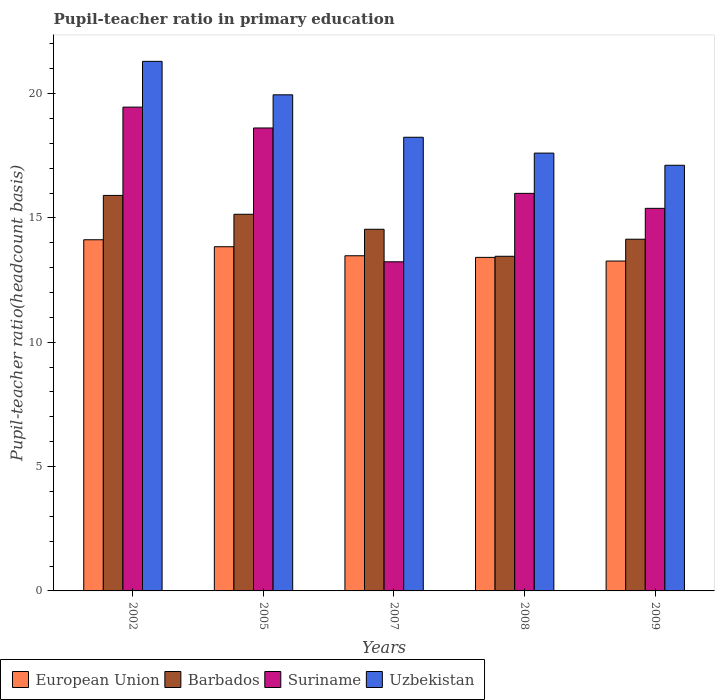How many different coloured bars are there?
Make the answer very short. 4. How many groups of bars are there?
Your response must be concise. 5. Are the number of bars on each tick of the X-axis equal?
Give a very brief answer. Yes. What is the label of the 5th group of bars from the left?
Make the answer very short. 2009. In how many cases, is the number of bars for a given year not equal to the number of legend labels?
Provide a short and direct response. 0. What is the pupil-teacher ratio in primary education in Barbados in 2007?
Your answer should be compact. 14.54. Across all years, what is the maximum pupil-teacher ratio in primary education in European Union?
Keep it short and to the point. 14.12. Across all years, what is the minimum pupil-teacher ratio in primary education in Uzbekistan?
Give a very brief answer. 17.12. In which year was the pupil-teacher ratio in primary education in Barbados maximum?
Keep it short and to the point. 2002. What is the total pupil-teacher ratio in primary education in Barbados in the graph?
Your answer should be very brief. 73.19. What is the difference between the pupil-teacher ratio in primary education in Uzbekistan in 2005 and that in 2009?
Provide a succinct answer. 2.83. What is the difference between the pupil-teacher ratio in primary education in Suriname in 2007 and the pupil-teacher ratio in primary education in Uzbekistan in 2002?
Provide a succinct answer. -8.06. What is the average pupil-teacher ratio in primary education in Suriname per year?
Your answer should be compact. 16.53. In the year 2007, what is the difference between the pupil-teacher ratio in primary education in European Union and pupil-teacher ratio in primary education in Suriname?
Ensure brevity in your answer.  0.24. What is the ratio of the pupil-teacher ratio in primary education in Barbados in 2005 to that in 2008?
Offer a very short reply. 1.13. Is the difference between the pupil-teacher ratio in primary education in European Union in 2002 and 2005 greater than the difference between the pupil-teacher ratio in primary education in Suriname in 2002 and 2005?
Provide a succinct answer. No. What is the difference between the highest and the second highest pupil-teacher ratio in primary education in Barbados?
Provide a short and direct response. 0.76. What is the difference between the highest and the lowest pupil-teacher ratio in primary education in European Union?
Provide a succinct answer. 0.86. Is the sum of the pupil-teacher ratio in primary education in Uzbekistan in 2005 and 2008 greater than the maximum pupil-teacher ratio in primary education in Barbados across all years?
Provide a succinct answer. Yes. What does the 4th bar from the left in 2008 represents?
Offer a terse response. Uzbekistan. What does the 4th bar from the right in 2007 represents?
Make the answer very short. European Union. Is it the case that in every year, the sum of the pupil-teacher ratio in primary education in European Union and pupil-teacher ratio in primary education in Barbados is greater than the pupil-teacher ratio in primary education in Uzbekistan?
Keep it short and to the point. Yes. How many bars are there?
Provide a short and direct response. 20. How many years are there in the graph?
Your answer should be very brief. 5. Are the values on the major ticks of Y-axis written in scientific E-notation?
Keep it short and to the point. No. Does the graph contain any zero values?
Keep it short and to the point. No. How are the legend labels stacked?
Keep it short and to the point. Horizontal. What is the title of the graph?
Your response must be concise. Pupil-teacher ratio in primary education. Does "Slovak Republic" appear as one of the legend labels in the graph?
Offer a very short reply. No. What is the label or title of the Y-axis?
Offer a terse response. Pupil-teacher ratio(headcount basis). What is the Pupil-teacher ratio(headcount basis) of European Union in 2002?
Your response must be concise. 14.12. What is the Pupil-teacher ratio(headcount basis) in Barbados in 2002?
Your answer should be very brief. 15.9. What is the Pupil-teacher ratio(headcount basis) in Suriname in 2002?
Offer a terse response. 19.45. What is the Pupil-teacher ratio(headcount basis) in Uzbekistan in 2002?
Offer a very short reply. 21.29. What is the Pupil-teacher ratio(headcount basis) of European Union in 2005?
Your answer should be compact. 13.84. What is the Pupil-teacher ratio(headcount basis) of Barbados in 2005?
Offer a very short reply. 15.15. What is the Pupil-teacher ratio(headcount basis) of Suriname in 2005?
Provide a succinct answer. 18.62. What is the Pupil-teacher ratio(headcount basis) in Uzbekistan in 2005?
Ensure brevity in your answer.  19.95. What is the Pupil-teacher ratio(headcount basis) of European Union in 2007?
Provide a succinct answer. 13.48. What is the Pupil-teacher ratio(headcount basis) of Barbados in 2007?
Offer a very short reply. 14.54. What is the Pupil-teacher ratio(headcount basis) in Suriname in 2007?
Your response must be concise. 13.23. What is the Pupil-teacher ratio(headcount basis) in Uzbekistan in 2007?
Make the answer very short. 18.24. What is the Pupil-teacher ratio(headcount basis) in European Union in 2008?
Your answer should be very brief. 13.41. What is the Pupil-teacher ratio(headcount basis) of Barbados in 2008?
Ensure brevity in your answer.  13.46. What is the Pupil-teacher ratio(headcount basis) of Suriname in 2008?
Your response must be concise. 15.99. What is the Pupil-teacher ratio(headcount basis) of Uzbekistan in 2008?
Provide a succinct answer. 17.61. What is the Pupil-teacher ratio(headcount basis) in European Union in 2009?
Give a very brief answer. 13.27. What is the Pupil-teacher ratio(headcount basis) of Barbados in 2009?
Give a very brief answer. 14.14. What is the Pupil-teacher ratio(headcount basis) in Suriname in 2009?
Your answer should be compact. 15.38. What is the Pupil-teacher ratio(headcount basis) in Uzbekistan in 2009?
Your answer should be very brief. 17.12. Across all years, what is the maximum Pupil-teacher ratio(headcount basis) in European Union?
Provide a succinct answer. 14.12. Across all years, what is the maximum Pupil-teacher ratio(headcount basis) of Barbados?
Give a very brief answer. 15.9. Across all years, what is the maximum Pupil-teacher ratio(headcount basis) in Suriname?
Offer a terse response. 19.45. Across all years, what is the maximum Pupil-teacher ratio(headcount basis) in Uzbekistan?
Make the answer very short. 21.29. Across all years, what is the minimum Pupil-teacher ratio(headcount basis) of European Union?
Your answer should be compact. 13.27. Across all years, what is the minimum Pupil-teacher ratio(headcount basis) in Barbados?
Make the answer very short. 13.46. Across all years, what is the minimum Pupil-teacher ratio(headcount basis) in Suriname?
Give a very brief answer. 13.23. Across all years, what is the minimum Pupil-teacher ratio(headcount basis) in Uzbekistan?
Your answer should be compact. 17.12. What is the total Pupil-teacher ratio(headcount basis) in European Union in the graph?
Keep it short and to the point. 68.12. What is the total Pupil-teacher ratio(headcount basis) in Barbados in the graph?
Make the answer very short. 73.19. What is the total Pupil-teacher ratio(headcount basis) in Suriname in the graph?
Keep it short and to the point. 82.67. What is the total Pupil-teacher ratio(headcount basis) in Uzbekistan in the graph?
Your answer should be very brief. 94.21. What is the difference between the Pupil-teacher ratio(headcount basis) of European Union in 2002 and that in 2005?
Make the answer very short. 0.28. What is the difference between the Pupil-teacher ratio(headcount basis) of Barbados in 2002 and that in 2005?
Your response must be concise. 0.76. What is the difference between the Pupil-teacher ratio(headcount basis) of Suriname in 2002 and that in 2005?
Ensure brevity in your answer.  0.84. What is the difference between the Pupil-teacher ratio(headcount basis) of Uzbekistan in 2002 and that in 2005?
Offer a terse response. 1.35. What is the difference between the Pupil-teacher ratio(headcount basis) in European Union in 2002 and that in 2007?
Keep it short and to the point. 0.64. What is the difference between the Pupil-teacher ratio(headcount basis) of Barbados in 2002 and that in 2007?
Your answer should be very brief. 1.36. What is the difference between the Pupil-teacher ratio(headcount basis) in Suriname in 2002 and that in 2007?
Keep it short and to the point. 6.22. What is the difference between the Pupil-teacher ratio(headcount basis) of Uzbekistan in 2002 and that in 2007?
Your answer should be compact. 3.05. What is the difference between the Pupil-teacher ratio(headcount basis) of European Union in 2002 and that in 2008?
Provide a short and direct response. 0.71. What is the difference between the Pupil-teacher ratio(headcount basis) of Barbados in 2002 and that in 2008?
Your answer should be very brief. 2.45. What is the difference between the Pupil-teacher ratio(headcount basis) in Suriname in 2002 and that in 2008?
Ensure brevity in your answer.  3.47. What is the difference between the Pupil-teacher ratio(headcount basis) of Uzbekistan in 2002 and that in 2008?
Your response must be concise. 3.69. What is the difference between the Pupil-teacher ratio(headcount basis) in European Union in 2002 and that in 2009?
Offer a very short reply. 0.86. What is the difference between the Pupil-teacher ratio(headcount basis) in Barbados in 2002 and that in 2009?
Ensure brevity in your answer.  1.76. What is the difference between the Pupil-teacher ratio(headcount basis) in Suriname in 2002 and that in 2009?
Keep it short and to the point. 4.07. What is the difference between the Pupil-teacher ratio(headcount basis) of Uzbekistan in 2002 and that in 2009?
Your response must be concise. 4.18. What is the difference between the Pupil-teacher ratio(headcount basis) in European Union in 2005 and that in 2007?
Give a very brief answer. 0.36. What is the difference between the Pupil-teacher ratio(headcount basis) of Barbados in 2005 and that in 2007?
Your answer should be very brief. 0.6. What is the difference between the Pupil-teacher ratio(headcount basis) in Suriname in 2005 and that in 2007?
Keep it short and to the point. 5.38. What is the difference between the Pupil-teacher ratio(headcount basis) in Uzbekistan in 2005 and that in 2007?
Offer a very short reply. 1.71. What is the difference between the Pupil-teacher ratio(headcount basis) in European Union in 2005 and that in 2008?
Give a very brief answer. 0.43. What is the difference between the Pupil-teacher ratio(headcount basis) in Barbados in 2005 and that in 2008?
Keep it short and to the point. 1.69. What is the difference between the Pupil-teacher ratio(headcount basis) in Suriname in 2005 and that in 2008?
Give a very brief answer. 2.63. What is the difference between the Pupil-teacher ratio(headcount basis) of Uzbekistan in 2005 and that in 2008?
Provide a succinct answer. 2.34. What is the difference between the Pupil-teacher ratio(headcount basis) of European Union in 2005 and that in 2009?
Keep it short and to the point. 0.58. What is the difference between the Pupil-teacher ratio(headcount basis) of Barbados in 2005 and that in 2009?
Your response must be concise. 1. What is the difference between the Pupil-teacher ratio(headcount basis) in Suriname in 2005 and that in 2009?
Offer a terse response. 3.23. What is the difference between the Pupil-teacher ratio(headcount basis) in Uzbekistan in 2005 and that in 2009?
Ensure brevity in your answer.  2.83. What is the difference between the Pupil-teacher ratio(headcount basis) in European Union in 2007 and that in 2008?
Your response must be concise. 0.07. What is the difference between the Pupil-teacher ratio(headcount basis) in Barbados in 2007 and that in 2008?
Ensure brevity in your answer.  1.09. What is the difference between the Pupil-teacher ratio(headcount basis) in Suriname in 2007 and that in 2008?
Keep it short and to the point. -2.75. What is the difference between the Pupil-teacher ratio(headcount basis) in Uzbekistan in 2007 and that in 2008?
Give a very brief answer. 0.64. What is the difference between the Pupil-teacher ratio(headcount basis) of European Union in 2007 and that in 2009?
Offer a terse response. 0.21. What is the difference between the Pupil-teacher ratio(headcount basis) in Barbados in 2007 and that in 2009?
Make the answer very short. 0.4. What is the difference between the Pupil-teacher ratio(headcount basis) in Suriname in 2007 and that in 2009?
Your response must be concise. -2.15. What is the difference between the Pupil-teacher ratio(headcount basis) of Uzbekistan in 2007 and that in 2009?
Make the answer very short. 1.13. What is the difference between the Pupil-teacher ratio(headcount basis) of European Union in 2008 and that in 2009?
Provide a succinct answer. 0.15. What is the difference between the Pupil-teacher ratio(headcount basis) of Barbados in 2008 and that in 2009?
Your answer should be compact. -0.69. What is the difference between the Pupil-teacher ratio(headcount basis) of Suriname in 2008 and that in 2009?
Give a very brief answer. 0.6. What is the difference between the Pupil-teacher ratio(headcount basis) in Uzbekistan in 2008 and that in 2009?
Offer a very short reply. 0.49. What is the difference between the Pupil-teacher ratio(headcount basis) in European Union in 2002 and the Pupil-teacher ratio(headcount basis) in Barbados in 2005?
Your response must be concise. -1.02. What is the difference between the Pupil-teacher ratio(headcount basis) in European Union in 2002 and the Pupil-teacher ratio(headcount basis) in Suriname in 2005?
Your response must be concise. -4.49. What is the difference between the Pupil-teacher ratio(headcount basis) of European Union in 2002 and the Pupil-teacher ratio(headcount basis) of Uzbekistan in 2005?
Your answer should be very brief. -5.83. What is the difference between the Pupil-teacher ratio(headcount basis) of Barbados in 2002 and the Pupil-teacher ratio(headcount basis) of Suriname in 2005?
Your response must be concise. -2.71. What is the difference between the Pupil-teacher ratio(headcount basis) of Barbados in 2002 and the Pupil-teacher ratio(headcount basis) of Uzbekistan in 2005?
Offer a very short reply. -4.05. What is the difference between the Pupil-teacher ratio(headcount basis) of Suriname in 2002 and the Pupil-teacher ratio(headcount basis) of Uzbekistan in 2005?
Keep it short and to the point. -0.49. What is the difference between the Pupil-teacher ratio(headcount basis) in European Union in 2002 and the Pupil-teacher ratio(headcount basis) in Barbados in 2007?
Your answer should be compact. -0.42. What is the difference between the Pupil-teacher ratio(headcount basis) in European Union in 2002 and the Pupil-teacher ratio(headcount basis) in Suriname in 2007?
Your answer should be very brief. 0.89. What is the difference between the Pupil-teacher ratio(headcount basis) in European Union in 2002 and the Pupil-teacher ratio(headcount basis) in Uzbekistan in 2007?
Make the answer very short. -4.12. What is the difference between the Pupil-teacher ratio(headcount basis) in Barbados in 2002 and the Pupil-teacher ratio(headcount basis) in Suriname in 2007?
Your response must be concise. 2.67. What is the difference between the Pupil-teacher ratio(headcount basis) in Barbados in 2002 and the Pupil-teacher ratio(headcount basis) in Uzbekistan in 2007?
Your answer should be compact. -2.34. What is the difference between the Pupil-teacher ratio(headcount basis) in Suriname in 2002 and the Pupil-teacher ratio(headcount basis) in Uzbekistan in 2007?
Offer a terse response. 1.21. What is the difference between the Pupil-teacher ratio(headcount basis) of European Union in 2002 and the Pupil-teacher ratio(headcount basis) of Barbados in 2008?
Keep it short and to the point. 0.66. What is the difference between the Pupil-teacher ratio(headcount basis) in European Union in 2002 and the Pupil-teacher ratio(headcount basis) in Suriname in 2008?
Offer a terse response. -1.87. What is the difference between the Pupil-teacher ratio(headcount basis) of European Union in 2002 and the Pupil-teacher ratio(headcount basis) of Uzbekistan in 2008?
Your response must be concise. -3.48. What is the difference between the Pupil-teacher ratio(headcount basis) of Barbados in 2002 and the Pupil-teacher ratio(headcount basis) of Suriname in 2008?
Ensure brevity in your answer.  -0.08. What is the difference between the Pupil-teacher ratio(headcount basis) in Barbados in 2002 and the Pupil-teacher ratio(headcount basis) in Uzbekistan in 2008?
Give a very brief answer. -1.7. What is the difference between the Pupil-teacher ratio(headcount basis) of Suriname in 2002 and the Pupil-teacher ratio(headcount basis) of Uzbekistan in 2008?
Provide a short and direct response. 1.85. What is the difference between the Pupil-teacher ratio(headcount basis) of European Union in 2002 and the Pupil-teacher ratio(headcount basis) of Barbados in 2009?
Give a very brief answer. -0.02. What is the difference between the Pupil-teacher ratio(headcount basis) of European Union in 2002 and the Pupil-teacher ratio(headcount basis) of Suriname in 2009?
Your answer should be compact. -1.26. What is the difference between the Pupil-teacher ratio(headcount basis) in European Union in 2002 and the Pupil-teacher ratio(headcount basis) in Uzbekistan in 2009?
Provide a succinct answer. -2.99. What is the difference between the Pupil-teacher ratio(headcount basis) in Barbados in 2002 and the Pupil-teacher ratio(headcount basis) in Suriname in 2009?
Offer a terse response. 0.52. What is the difference between the Pupil-teacher ratio(headcount basis) in Barbados in 2002 and the Pupil-teacher ratio(headcount basis) in Uzbekistan in 2009?
Keep it short and to the point. -1.21. What is the difference between the Pupil-teacher ratio(headcount basis) in Suriname in 2002 and the Pupil-teacher ratio(headcount basis) in Uzbekistan in 2009?
Your answer should be compact. 2.34. What is the difference between the Pupil-teacher ratio(headcount basis) in European Union in 2005 and the Pupil-teacher ratio(headcount basis) in Barbados in 2007?
Your answer should be very brief. -0.7. What is the difference between the Pupil-teacher ratio(headcount basis) of European Union in 2005 and the Pupil-teacher ratio(headcount basis) of Suriname in 2007?
Make the answer very short. 0.61. What is the difference between the Pupil-teacher ratio(headcount basis) in European Union in 2005 and the Pupil-teacher ratio(headcount basis) in Uzbekistan in 2007?
Provide a short and direct response. -4.4. What is the difference between the Pupil-teacher ratio(headcount basis) in Barbados in 2005 and the Pupil-teacher ratio(headcount basis) in Suriname in 2007?
Give a very brief answer. 1.91. What is the difference between the Pupil-teacher ratio(headcount basis) of Barbados in 2005 and the Pupil-teacher ratio(headcount basis) of Uzbekistan in 2007?
Offer a terse response. -3.1. What is the difference between the Pupil-teacher ratio(headcount basis) in Suriname in 2005 and the Pupil-teacher ratio(headcount basis) in Uzbekistan in 2007?
Give a very brief answer. 0.37. What is the difference between the Pupil-teacher ratio(headcount basis) in European Union in 2005 and the Pupil-teacher ratio(headcount basis) in Barbados in 2008?
Give a very brief answer. 0.38. What is the difference between the Pupil-teacher ratio(headcount basis) of European Union in 2005 and the Pupil-teacher ratio(headcount basis) of Suriname in 2008?
Offer a very short reply. -2.15. What is the difference between the Pupil-teacher ratio(headcount basis) of European Union in 2005 and the Pupil-teacher ratio(headcount basis) of Uzbekistan in 2008?
Your answer should be compact. -3.76. What is the difference between the Pupil-teacher ratio(headcount basis) of Barbados in 2005 and the Pupil-teacher ratio(headcount basis) of Suriname in 2008?
Your answer should be very brief. -0.84. What is the difference between the Pupil-teacher ratio(headcount basis) in Barbados in 2005 and the Pupil-teacher ratio(headcount basis) in Uzbekistan in 2008?
Your answer should be compact. -2.46. What is the difference between the Pupil-teacher ratio(headcount basis) in Suriname in 2005 and the Pupil-teacher ratio(headcount basis) in Uzbekistan in 2008?
Your answer should be very brief. 1.01. What is the difference between the Pupil-teacher ratio(headcount basis) of European Union in 2005 and the Pupil-teacher ratio(headcount basis) of Barbados in 2009?
Make the answer very short. -0.3. What is the difference between the Pupil-teacher ratio(headcount basis) of European Union in 2005 and the Pupil-teacher ratio(headcount basis) of Suriname in 2009?
Your answer should be very brief. -1.54. What is the difference between the Pupil-teacher ratio(headcount basis) in European Union in 2005 and the Pupil-teacher ratio(headcount basis) in Uzbekistan in 2009?
Offer a terse response. -3.28. What is the difference between the Pupil-teacher ratio(headcount basis) in Barbados in 2005 and the Pupil-teacher ratio(headcount basis) in Suriname in 2009?
Provide a succinct answer. -0.24. What is the difference between the Pupil-teacher ratio(headcount basis) in Barbados in 2005 and the Pupil-teacher ratio(headcount basis) in Uzbekistan in 2009?
Ensure brevity in your answer.  -1.97. What is the difference between the Pupil-teacher ratio(headcount basis) of Suriname in 2005 and the Pupil-teacher ratio(headcount basis) of Uzbekistan in 2009?
Provide a short and direct response. 1.5. What is the difference between the Pupil-teacher ratio(headcount basis) of European Union in 2007 and the Pupil-teacher ratio(headcount basis) of Barbados in 2008?
Your answer should be compact. 0.02. What is the difference between the Pupil-teacher ratio(headcount basis) in European Union in 2007 and the Pupil-teacher ratio(headcount basis) in Suriname in 2008?
Ensure brevity in your answer.  -2.51. What is the difference between the Pupil-teacher ratio(headcount basis) of European Union in 2007 and the Pupil-teacher ratio(headcount basis) of Uzbekistan in 2008?
Make the answer very short. -4.13. What is the difference between the Pupil-teacher ratio(headcount basis) of Barbados in 2007 and the Pupil-teacher ratio(headcount basis) of Suriname in 2008?
Ensure brevity in your answer.  -1.44. What is the difference between the Pupil-teacher ratio(headcount basis) in Barbados in 2007 and the Pupil-teacher ratio(headcount basis) in Uzbekistan in 2008?
Your response must be concise. -3.06. What is the difference between the Pupil-teacher ratio(headcount basis) of Suriname in 2007 and the Pupil-teacher ratio(headcount basis) of Uzbekistan in 2008?
Ensure brevity in your answer.  -4.37. What is the difference between the Pupil-teacher ratio(headcount basis) in European Union in 2007 and the Pupil-teacher ratio(headcount basis) in Barbados in 2009?
Your answer should be very brief. -0.67. What is the difference between the Pupil-teacher ratio(headcount basis) in European Union in 2007 and the Pupil-teacher ratio(headcount basis) in Suriname in 2009?
Your answer should be compact. -1.91. What is the difference between the Pupil-teacher ratio(headcount basis) of European Union in 2007 and the Pupil-teacher ratio(headcount basis) of Uzbekistan in 2009?
Make the answer very short. -3.64. What is the difference between the Pupil-teacher ratio(headcount basis) in Barbados in 2007 and the Pupil-teacher ratio(headcount basis) in Suriname in 2009?
Your response must be concise. -0.84. What is the difference between the Pupil-teacher ratio(headcount basis) of Barbados in 2007 and the Pupil-teacher ratio(headcount basis) of Uzbekistan in 2009?
Provide a succinct answer. -2.57. What is the difference between the Pupil-teacher ratio(headcount basis) in Suriname in 2007 and the Pupil-teacher ratio(headcount basis) in Uzbekistan in 2009?
Make the answer very short. -3.88. What is the difference between the Pupil-teacher ratio(headcount basis) of European Union in 2008 and the Pupil-teacher ratio(headcount basis) of Barbados in 2009?
Provide a succinct answer. -0.73. What is the difference between the Pupil-teacher ratio(headcount basis) in European Union in 2008 and the Pupil-teacher ratio(headcount basis) in Suriname in 2009?
Give a very brief answer. -1.97. What is the difference between the Pupil-teacher ratio(headcount basis) of European Union in 2008 and the Pupil-teacher ratio(headcount basis) of Uzbekistan in 2009?
Keep it short and to the point. -3.7. What is the difference between the Pupil-teacher ratio(headcount basis) in Barbados in 2008 and the Pupil-teacher ratio(headcount basis) in Suriname in 2009?
Provide a short and direct response. -1.93. What is the difference between the Pupil-teacher ratio(headcount basis) of Barbados in 2008 and the Pupil-teacher ratio(headcount basis) of Uzbekistan in 2009?
Make the answer very short. -3.66. What is the difference between the Pupil-teacher ratio(headcount basis) in Suriname in 2008 and the Pupil-teacher ratio(headcount basis) in Uzbekistan in 2009?
Offer a terse response. -1.13. What is the average Pupil-teacher ratio(headcount basis) of European Union per year?
Make the answer very short. 13.62. What is the average Pupil-teacher ratio(headcount basis) of Barbados per year?
Offer a terse response. 14.64. What is the average Pupil-teacher ratio(headcount basis) in Suriname per year?
Your answer should be very brief. 16.53. What is the average Pupil-teacher ratio(headcount basis) in Uzbekistan per year?
Make the answer very short. 18.84. In the year 2002, what is the difference between the Pupil-teacher ratio(headcount basis) in European Union and Pupil-teacher ratio(headcount basis) in Barbados?
Offer a terse response. -1.78. In the year 2002, what is the difference between the Pupil-teacher ratio(headcount basis) in European Union and Pupil-teacher ratio(headcount basis) in Suriname?
Offer a very short reply. -5.33. In the year 2002, what is the difference between the Pupil-teacher ratio(headcount basis) of European Union and Pupil-teacher ratio(headcount basis) of Uzbekistan?
Keep it short and to the point. -7.17. In the year 2002, what is the difference between the Pupil-teacher ratio(headcount basis) in Barbados and Pupil-teacher ratio(headcount basis) in Suriname?
Give a very brief answer. -3.55. In the year 2002, what is the difference between the Pupil-teacher ratio(headcount basis) of Barbados and Pupil-teacher ratio(headcount basis) of Uzbekistan?
Make the answer very short. -5.39. In the year 2002, what is the difference between the Pupil-teacher ratio(headcount basis) in Suriname and Pupil-teacher ratio(headcount basis) in Uzbekistan?
Keep it short and to the point. -1.84. In the year 2005, what is the difference between the Pupil-teacher ratio(headcount basis) of European Union and Pupil-teacher ratio(headcount basis) of Barbados?
Keep it short and to the point. -1.3. In the year 2005, what is the difference between the Pupil-teacher ratio(headcount basis) in European Union and Pupil-teacher ratio(headcount basis) in Suriname?
Offer a very short reply. -4.78. In the year 2005, what is the difference between the Pupil-teacher ratio(headcount basis) in European Union and Pupil-teacher ratio(headcount basis) in Uzbekistan?
Ensure brevity in your answer.  -6.11. In the year 2005, what is the difference between the Pupil-teacher ratio(headcount basis) in Barbados and Pupil-teacher ratio(headcount basis) in Suriname?
Your answer should be very brief. -3.47. In the year 2005, what is the difference between the Pupil-teacher ratio(headcount basis) in Barbados and Pupil-teacher ratio(headcount basis) in Uzbekistan?
Provide a succinct answer. -4.8. In the year 2005, what is the difference between the Pupil-teacher ratio(headcount basis) in Suriname and Pupil-teacher ratio(headcount basis) in Uzbekistan?
Keep it short and to the point. -1.33. In the year 2007, what is the difference between the Pupil-teacher ratio(headcount basis) in European Union and Pupil-teacher ratio(headcount basis) in Barbados?
Ensure brevity in your answer.  -1.06. In the year 2007, what is the difference between the Pupil-teacher ratio(headcount basis) in European Union and Pupil-teacher ratio(headcount basis) in Suriname?
Provide a succinct answer. 0.24. In the year 2007, what is the difference between the Pupil-teacher ratio(headcount basis) of European Union and Pupil-teacher ratio(headcount basis) of Uzbekistan?
Make the answer very short. -4.76. In the year 2007, what is the difference between the Pupil-teacher ratio(headcount basis) in Barbados and Pupil-teacher ratio(headcount basis) in Suriname?
Offer a very short reply. 1.31. In the year 2007, what is the difference between the Pupil-teacher ratio(headcount basis) of Barbados and Pupil-teacher ratio(headcount basis) of Uzbekistan?
Keep it short and to the point. -3.7. In the year 2007, what is the difference between the Pupil-teacher ratio(headcount basis) in Suriname and Pupil-teacher ratio(headcount basis) in Uzbekistan?
Make the answer very short. -5.01. In the year 2008, what is the difference between the Pupil-teacher ratio(headcount basis) in European Union and Pupil-teacher ratio(headcount basis) in Barbados?
Provide a succinct answer. -0.04. In the year 2008, what is the difference between the Pupil-teacher ratio(headcount basis) of European Union and Pupil-teacher ratio(headcount basis) of Suriname?
Ensure brevity in your answer.  -2.57. In the year 2008, what is the difference between the Pupil-teacher ratio(headcount basis) of European Union and Pupil-teacher ratio(headcount basis) of Uzbekistan?
Give a very brief answer. -4.19. In the year 2008, what is the difference between the Pupil-teacher ratio(headcount basis) in Barbados and Pupil-teacher ratio(headcount basis) in Suriname?
Give a very brief answer. -2.53. In the year 2008, what is the difference between the Pupil-teacher ratio(headcount basis) in Barbados and Pupil-teacher ratio(headcount basis) in Uzbekistan?
Provide a succinct answer. -4.15. In the year 2008, what is the difference between the Pupil-teacher ratio(headcount basis) in Suriname and Pupil-teacher ratio(headcount basis) in Uzbekistan?
Provide a short and direct response. -1.62. In the year 2009, what is the difference between the Pupil-teacher ratio(headcount basis) in European Union and Pupil-teacher ratio(headcount basis) in Barbados?
Offer a very short reply. -0.88. In the year 2009, what is the difference between the Pupil-teacher ratio(headcount basis) in European Union and Pupil-teacher ratio(headcount basis) in Suriname?
Your response must be concise. -2.12. In the year 2009, what is the difference between the Pupil-teacher ratio(headcount basis) of European Union and Pupil-teacher ratio(headcount basis) of Uzbekistan?
Offer a terse response. -3.85. In the year 2009, what is the difference between the Pupil-teacher ratio(headcount basis) in Barbados and Pupil-teacher ratio(headcount basis) in Suriname?
Your answer should be very brief. -1.24. In the year 2009, what is the difference between the Pupil-teacher ratio(headcount basis) in Barbados and Pupil-teacher ratio(headcount basis) in Uzbekistan?
Offer a terse response. -2.97. In the year 2009, what is the difference between the Pupil-teacher ratio(headcount basis) of Suriname and Pupil-teacher ratio(headcount basis) of Uzbekistan?
Your answer should be compact. -1.73. What is the ratio of the Pupil-teacher ratio(headcount basis) in European Union in 2002 to that in 2005?
Make the answer very short. 1.02. What is the ratio of the Pupil-teacher ratio(headcount basis) of Barbados in 2002 to that in 2005?
Make the answer very short. 1.05. What is the ratio of the Pupil-teacher ratio(headcount basis) in Suriname in 2002 to that in 2005?
Offer a very short reply. 1.04. What is the ratio of the Pupil-teacher ratio(headcount basis) in Uzbekistan in 2002 to that in 2005?
Offer a very short reply. 1.07. What is the ratio of the Pupil-teacher ratio(headcount basis) in European Union in 2002 to that in 2007?
Keep it short and to the point. 1.05. What is the ratio of the Pupil-teacher ratio(headcount basis) of Barbados in 2002 to that in 2007?
Ensure brevity in your answer.  1.09. What is the ratio of the Pupil-teacher ratio(headcount basis) in Suriname in 2002 to that in 2007?
Offer a terse response. 1.47. What is the ratio of the Pupil-teacher ratio(headcount basis) in Uzbekistan in 2002 to that in 2007?
Provide a short and direct response. 1.17. What is the ratio of the Pupil-teacher ratio(headcount basis) of European Union in 2002 to that in 2008?
Your answer should be compact. 1.05. What is the ratio of the Pupil-teacher ratio(headcount basis) of Barbados in 2002 to that in 2008?
Your answer should be very brief. 1.18. What is the ratio of the Pupil-teacher ratio(headcount basis) of Suriname in 2002 to that in 2008?
Ensure brevity in your answer.  1.22. What is the ratio of the Pupil-teacher ratio(headcount basis) of Uzbekistan in 2002 to that in 2008?
Offer a terse response. 1.21. What is the ratio of the Pupil-teacher ratio(headcount basis) of European Union in 2002 to that in 2009?
Provide a short and direct response. 1.06. What is the ratio of the Pupil-teacher ratio(headcount basis) of Barbados in 2002 to that in 2009?
Make the answer very short. 1.12. What is the ratio of the Pupil-teacher ratio(headcount basis) in Suriname in 2002 to that in 2009?
Keep it short and to the point. 1.26. What is the ratio of the Pupil-teacher ratio(headcount basis) in Uzbekistan in 2002 to that in 2009?
Provide a short and direct response. 1.24. What is the ratio of the Pupil-teacher ratio(headcount basis) in European Union in 2005 to that in 2007?
Provide a short and direct response. 1.03. What is the ratio of the Pupil-teacher ratio(headcount basis) of Barbados in 2005 to that in 2007?
Make the answer very short. 1.04. What is the ratio of the Pupil-teacher ratio(headcount basis) of Suriname in 2005 to that in 2007?
Your answer should be very brief. 1.41. What is the ratio of the Pupil-teacher ratio(headcount basis) of Uzbekistan in 2005 to that in 2007?
Your response must be concise. 1.09. What is the ratio of the Pupil-teacher ratio(headcount basis) in European Union in 2005 to that in 2008?
Give a very brief answer. 1.03. What is the ratio of the Pupil-teacher ratio(headcount basis) in Barbados in 2005 to that in 2008?
Keep it short and to the point. 1.13. What is the ratio of the Pupil-teacher ratio(headcount basis) of Suriname in 2005 to that in 2008?
Give a very brief answer. 1.16. What is the ratio of the Pupil-teacher ratio(headcount basis) in Uzbekistan in 2005 to that in 2008?
Make the answer very short. 1.13. What is the ratio of the Pupil-teacher ratio(headcount basis) in European Union in 2005 to that in 2009?
Your answer should be compact. 1.04. What is the ratio of the Pupil-teacher ratio(headcount basis) in Barbados in 2005 to that in 2009?
Make the answer very short. 1.07. What is the ratio of the Pupil-teacher ratio(headcount basis) of Suriname in 2005 to that in 2009?
Keep it short and to the point. 1.21. What is the ratio of the Pupil-teacher ratio(headcount basis) of Uzbekistan in 2005 to that in 2009?
Give a very brief answer. 1.17. What is the ratio of the Pupil-teacher ratio(headcount basis) in Barbados in 2007 to that in 2008?
Make the answer very short. 1.08. What is the ratio of the Pupil-teacher ratio(headcount basis) in Suriname in 2007 to that in 2008?
Offer a very short reply. 0.83. What is the ratio of the Pupil-teacher ratio(headcount basis) of Uzbekistan in 2007 to that in 2008?
Provide a short and direct response. 1.04. What is the ratio of the Pupil-teacher ratio(headcount basis) of Barbados in 2007 to that in 2009?
Offer a terse response. 1.03. What is the ratio of the Pupil-teacher ratio(headcount basis) in Suriname in 2007 to that in 2009?
Provide a succinct answer. 0.86. What is the ratio of the Pupil-teacher ratio(headcount basis) in Uzbekistan in 2007 to that in 2009?
Your answer should be very brief. 1.07. What is the ratio of the Pupil-teacher ratio(headcount basis) of European Union in 2008 to that in 2009?
Keep it short and to the point. 1.01. What is the ratio of the Pupil-teacher ratio(headcount basis) of Barbados in 2008 to that in 2009?
Make the answer very short. 0.95. What is the ratio of the Pupil-teacher ratio(headcount basis) of Suriname in 2008 to that in 2009?
Give a very brief answer. 1.04. What is the ratio of the Pupil-teacher ratio(headcount basis) of Uzbekistan in 2008 to that in 2009?
Provide a succinct answer. 1.03. What is the difference between the highest and the second highest Pupil-teacher ratio(headcount basis) of European Union?
Provide a succinct answer. 0.28. What is the difference between the highest and the second highest Pupil-teacher ratio(headcount basis) in Barbados?
Keep it short and to the point. 0.76. What is the difference between the highest and the second highest Pupil-teacher ratio(headcount basis) of Suriname?
Make the answer very short. 0.84. What is the difference between the highest and the second highest Pupil-teacher ratio(headcount basis) in Uzbekistan?
Your response must be concise. 1.35. What is the difference between the highest and the lowest Pupil-teacher ratio(headcount basis) of European Union?
Give a very brief answer. 0.86. What is the difference between the highest and the lowest Pupil-teacher ratio(headcount basis) in Barbados?
Your response must be concise. 2.45. What is the difference between the highest and the lowest Pupil-teacher ratio(headcount basis) of Suriname?
Give a very brief answer. 6.22. What is the difference between the highest and the lowest Pupil-teacher ratio(headcount basis) of Uzbekistan?
Keep it short and to the point. 4.18. 